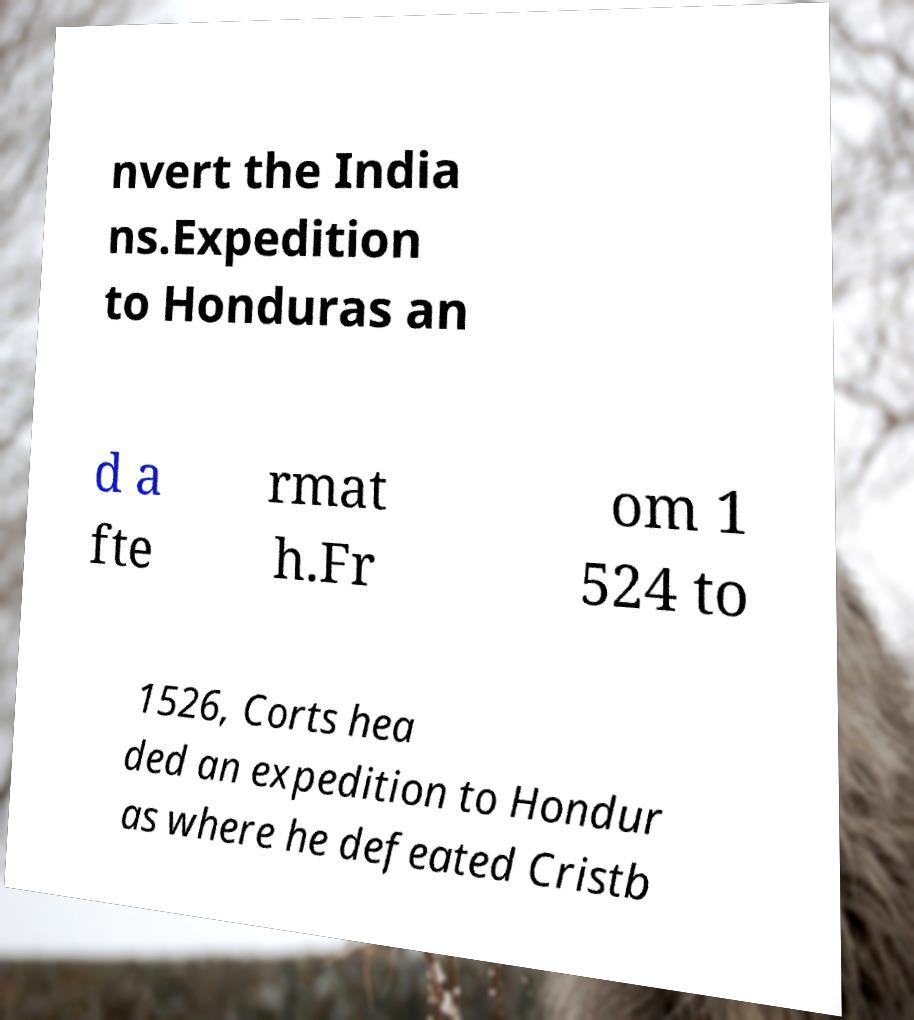Please identify and transcribe the text found in this image. nvert the India ns.Expedition to Honduras an d a fte rmat h.Fr om 1 524 to 1526, Corts hea ded an expedition to Hondur as where he defeated Cristb 